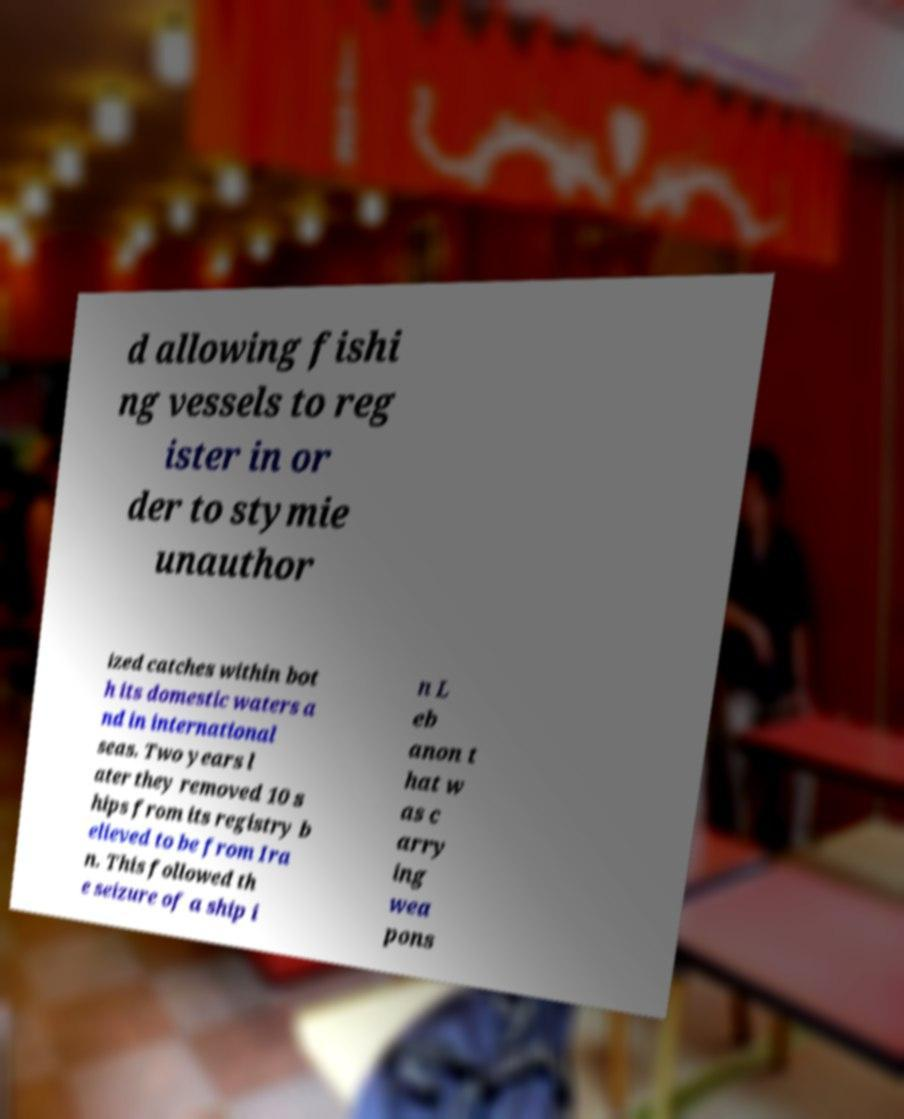Can you accurately transcribe the text from the provided image for me? d allowing fishi ng vessels to reg ister in or der to stymie unauthor ized catches within bot h its domestic waters a nd in international seas. Two years l ater they removed 10 s hips from its registry b elieved to be from Ira n. This followed th e seizure of a ship i n L eb anon t hat w as c arry ing wea pons 